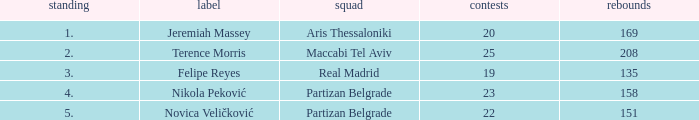What is the number of Games for Partizan Belgrade player Nikola Peković with a Rank of more than 4? None. 